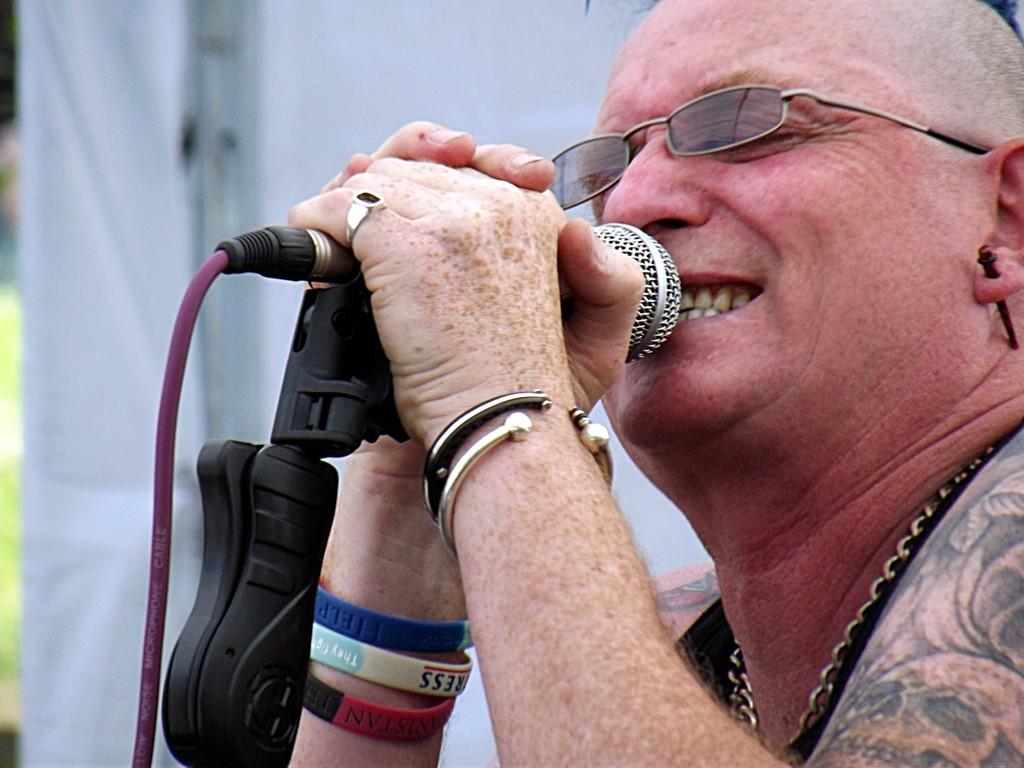What is the person in the image doing? The person in the image is holding a microphone. How is the microphone positioned in relation to the person? The microphone is placed in front of the person's mouth. What can be seen behind the person in the image? There is a white-colored banner behind the person. What type of drink is the person holding in the image? There is no drink visible in the image; the person is holding a microphone. What is the reason for the person to be standing near the gate in the image? There is no gate present in the image, and therefore no reason to be near one. 